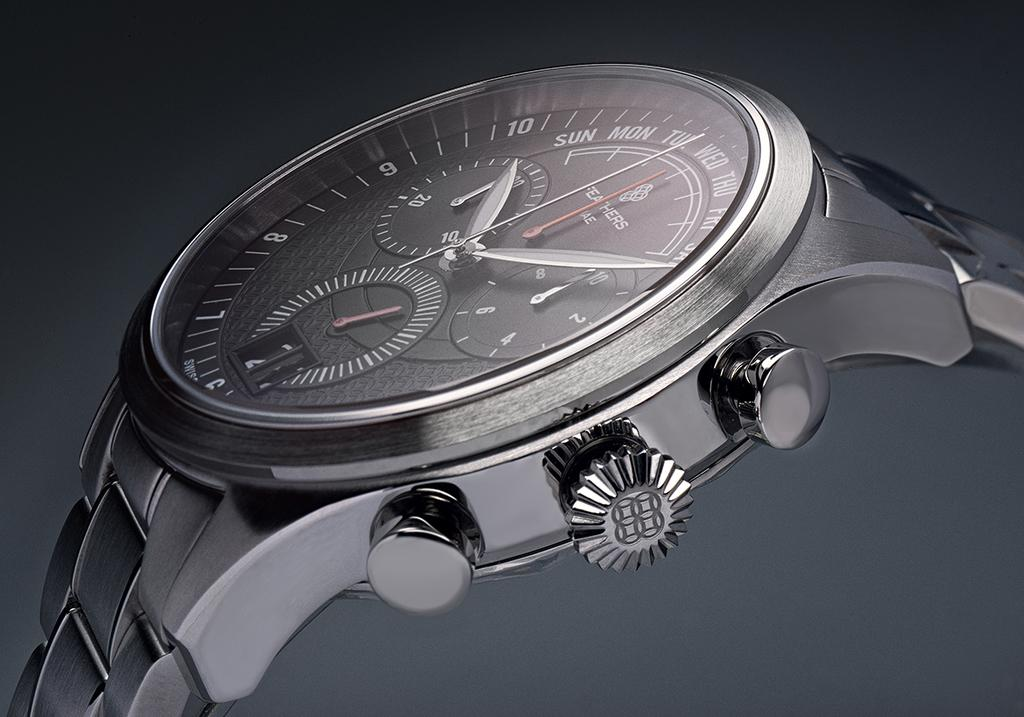Provide a one-sentence caption for the provided image. A watch with the day  and the time around 10:10. 